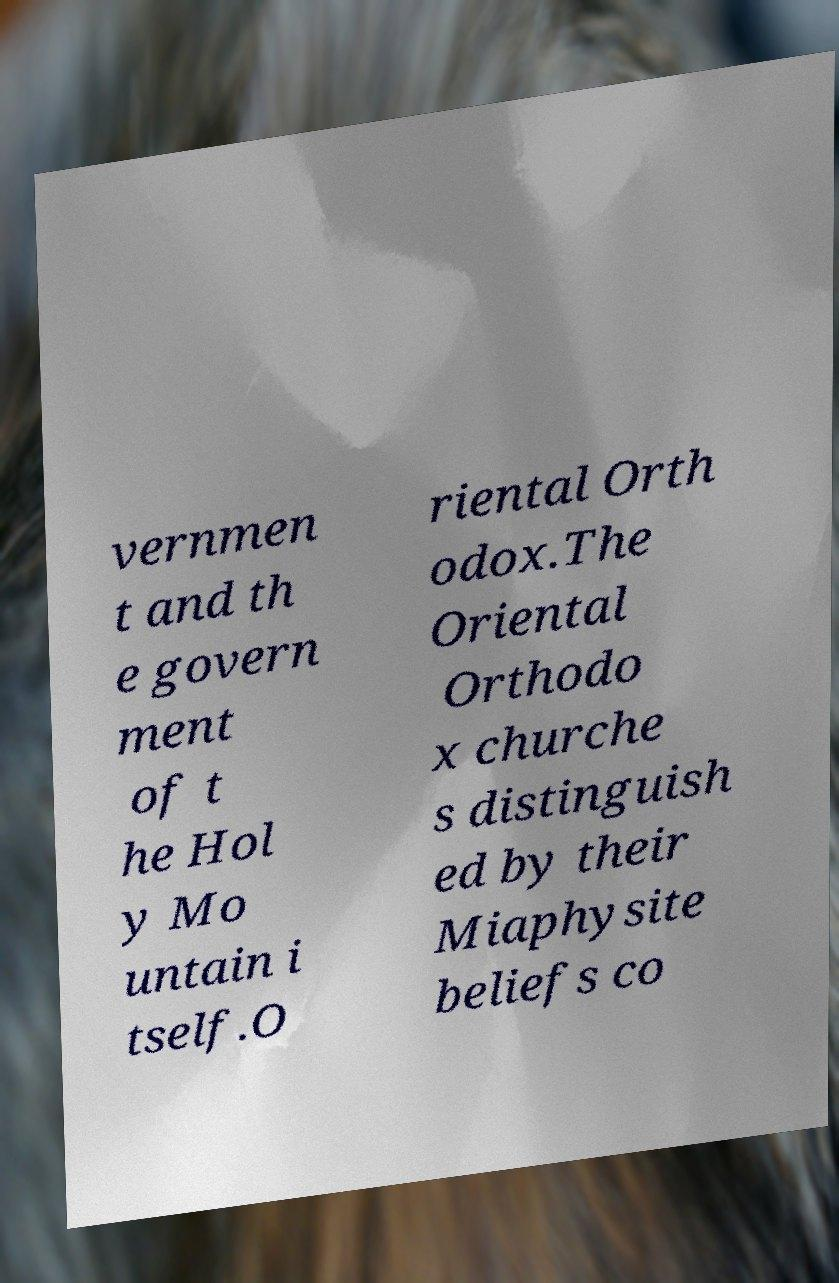Could you extract and type out the text from this image? vernmen t and th e govern ment of t he Hol y Mo untain i tself.O riental Orth odox.The Oriental Orthodo x churche s distinguish ed by their Miaphysite beliefs co 